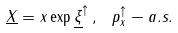Convert formula to latex. <formula><loc_0><loc_0><loc_500><loc_500>\underline { X } = x \exp \underline { \xi } ^ { \uparrow } \, , \, \ p _ { x } ^ { \uparrow } - a . s .</formula> 